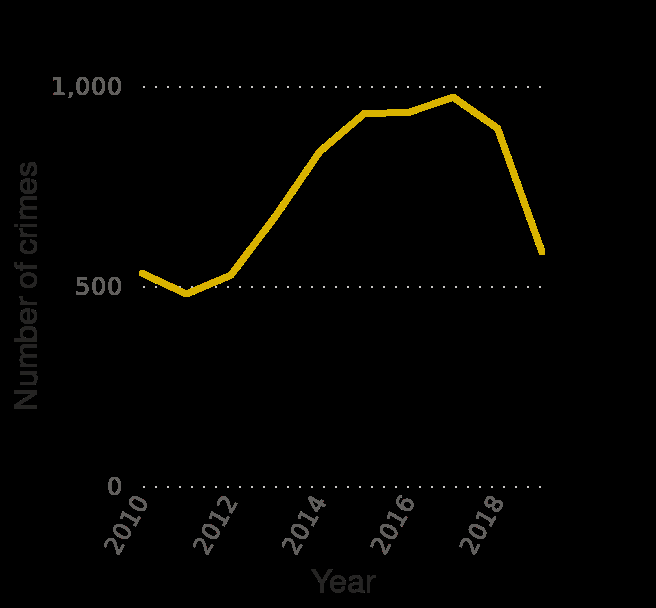<image>
please summary the statistics and relations of the chart The number of crimes steadily rises from the year 2011 and peaks during the year 2017. The number of crimes declines from roughly 1000 crimes in 2017 to under 600 crimes in 2019. 